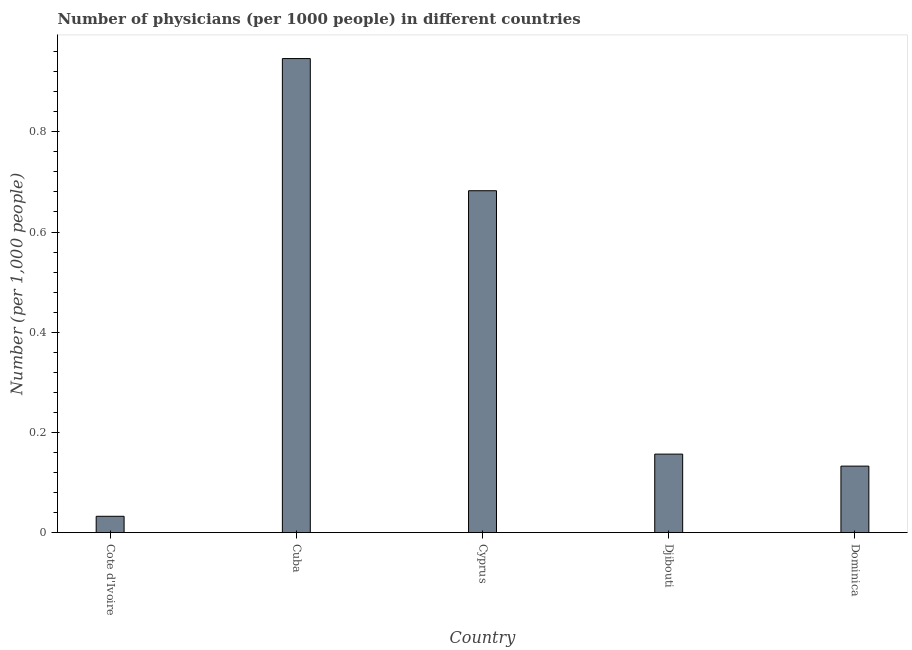What is the title of the graph?
Give a very brief answer. Number of physicians (per 1000 people) in different countries. What is the label or title of the X-axis?
Your answer should be compact. Country. What is the label or title of the Y-axis?
Give a very brief answer. Number (per 1,0 people). What is the number of physicians in Cyprus?
Keep it short and to the point. 0.68. Across all countries, what is the maximum number of physicians?
Ensure brevity in your answer.  0.95. Across all countries, what is the minimum number of physicians?
Your response must be concise. 0.03. In which country was the number of physicians maximum?
Your answer should be very brief. Cuba. In which country was the number of physicians minimum?
Keep it short and to the point. Cote d'Ivoire. What is the sum of the number of physicians?
Your answer should be compact. 1.95. What is the difference between the number of physicians in Cuba and Dominica?
Ensure brevity in your answer.  0.81. What is the average number of physicians per country?
Your response must be concise. 0.39. What is the median number of physicians?
Your response must be concise. 0.16. What is the ratio of the number of physicians in Cote d'Ivoire to that in Cuba?
Give a very brief answer. 0.03. What is the difference between the highest and the second highest number of physicians?
Ensure brevity in your answer.  0.26. Is the sum of the number of physicians in Cote d'Ivoire and Dominica greater than the maximum number of physicians across all countries?
Your response must be concise. No. What is the difference between the highest and the lowest number of physicians?
Your answer should be very brief. 0.91. How many bars are there?
Your answer should be very brief. 5. What is the difference between two consecutive major ticks on the Y-axis?
Provide a short and direct response. 0.2. What is the Number (per 1,000 people) of Cote d'Ivoire?
Give a very brief answer. 0.03. What is the Number (per 1,000 people) of Cuba?
Make the answer very short. 0.95. What is the Number (per 1,000 people) in Cyprus?
Offer a very short reply. 0.68. What is the Number (per 1,000 people) of Djibouti?
Offer a terse response. 0.16. What is the Number (per 1,000 people) in Dominica?
Make the answer very short. 0.13. What is the difference between the Number (per 1,000 people) in Cote d'Ivoire and Cuba?
Make the answer very short. -0.91. What is the difference between the Number (per 1,000 people) in Cote d'Ivoire and Cyprus?
Keep it short and to the point. -0.65. What is the difference between the Number (per 1,000 people) in Cote d'Ivoire and Djibouti?
Your answer should be compact. -0.12. What is the difference between the Number (per 1,000 people) in Cote d'Ivoire and Dominica?
Your answer should be very brief. -0.1. What is the difference between the Number (per 1,000 people) in Cuba and Cyprus?
Give a very brief answer. 0.26. What is the difference between the Number (per 1,000 people) in Cuba and Djibouti?
Your response must be concise. 0.79. What is the difference between the Number (per 1,000 people) in Cuba and Dominica?
Keep it short and to the point. 0.81. What is the difference between the Number (per 1,000 people) in Cyprus and Djibouti?
Keep it short and to the point. 0.53. What is the difference between the Number (per 1,000 people) in Cyprus and Dominica?
Provide a short and direct response. 0.55. What is the difference between the Number (per 1,000 people) in Djibouti and Dominica?
Give a very brief answer. 0.02. What is the ratio of the Number (per 1,000 people) in Cote d'Ivoire to that in Cuba?
Provide a succinct answer. 0.03. What is the ratio of the Number (per 1,000 people) in Cote d'Ivoire to that in Cyprus?
Offer a very short reply. 0.05. What is the ratio of the Number (per 1,000 people) in Cote d'Ivoire to that in Djibouti?
Provide a succinct answer. 0.21. What is the ratio of the Number (per 1,000 people) in Cote d'Ivoire to that in Dominica?
Offer a terse response. 0.24. What is the ratio of the Number (per 1,000 people) in Cuba to that in Cyprus?
Ensure brevity in your answer.  1.39. What is the ratio of the Number (per 1,000 people) in Cuba to that in Djibouti?
Offer a very short reply. 6.04. What is the ratio of the Number (per 1,000 people) in Cuba to that in Dominica?
Your response must be concise. 7.13. What is the ratio of the Number (per 1,000 people) in Cyprus to that in Djibouti?
Make the answer very short. 4.36. What is the ratio of the Number (per 1,000 people) in Cyprus to that in Dominica?
Provide a short and direct response. 5.14. What is the ratio of the Number (per 1,000 people) in Djibouti to that in Dominica?
Provide a succinct answer. 1.18. 